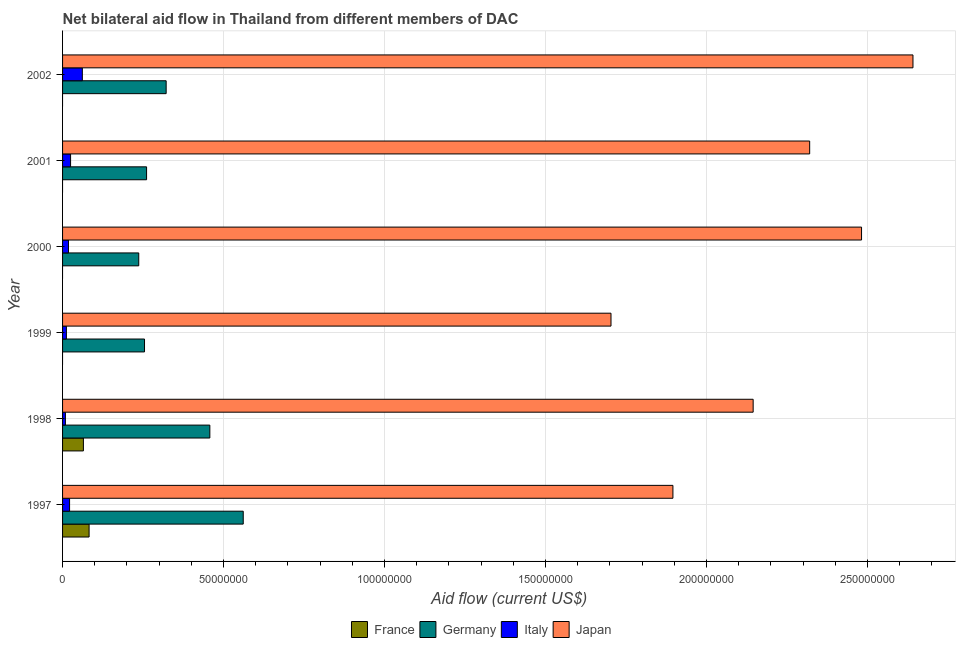Are the number of bars on each tick of the Y-axis equal?
Ensure brevity in your answer.  No. What is the label of the 5th group of bars from the top?
Your answer should be compact. 1998. In how many cases, is the number of bars for a given year not equal to the number of legend labels?
Ensure brevity in your answer.  4. What is the amount of aid given by italy in 1997?
Give a very brief answer. 2.18e+06. Across all years, what is the maximum amount of aid given by italy?
Ensure brevity in your answer.  6.14e+06. Across all years, what is the minimum amount of aid given by japan?
Provide a short and direct response. 1.70e+08. What is the total amount of aid given by japan in the graph?
Give a very brief answer. 1.32e+09. What is the difference between the amount of aid given by italy in 1997 and that in 1999?
Give a very brief answer. 9.90e+05. What is the difference between the amount of aid given by italy in 2001 and the amount of aid given by japan in 1998?
Your answer should be compact. -2.12e+08. What is the average amount of aid given by germany per year?
Offer a very short reply. 3.49e+07. In the year 1997, what is the difference between the amount of aid given by france and amount of aid given by germany?
Your answer should be compact. -4.79e+07. In how many years, is the amount of aid given by france greater than 60000000 US$?
Provide a succinct answer. 0. What is the ratio of the amount of aid given by germany in 1999 to that in 2002?
Your answer should be very brief. 0.79. Is the amount of aid given by italy in 1999 less than that in 2001?
Give a very brief answer. Yes. What is the difference between the highest and the second highest amount of aid given by japan?
Your answer should be compact. 1.60e+07. What is the difference between the highest and the lowest amount of aid given by germany?
Ensure brevity in your answer.  3.24e+07. Is it the case that in every year, the sum of the amount of aid given by germany and amount of aid given by japan is greater than the sum of amount of aid given by italy and amount of aid given by france?
Provide a succinct answer. Yes. Is it the case that in every year, the sum of the amount of aid given by france and amount of aid given by germany is greater than the amount of aid given by italy?
Give a very brief answer. Yes. Are all the bars in the graph horizontal?
Offer a very short reply. Yes. How many years are there in the graph?
Your answer should be very brief. 6. What is the difference between two consecutive major ticks on the X-axis?
Your answer should be compact. 5.00e+07. Does the graph contain grids?
Provide a short and direct response. Yes. How are the legend labels stacked?
Keep it short and to the point. Horizontal. What is the title of the graph?
Keep it short and to the point. Net bilateral aid flow in Thailand from different members of DAC. What is the label or title of the X-axis?
Your response must be concise. Aid flow (current US$). What is the label or title of the Y-axis?
Keep it short and to the point. Year. What is the Aid flow (current US$) of France in 1997?
Provide a succinct answer. 8.24e+06. What is the Aid flow (current US$) of Germany in 1997?
Offer a very short reply. 5.61e+07. What is the Aid flow (current US$) in Italy in 1997?
Provide a succinct answer. 2.18e+06. What is the Aid flow (current US$) in Japan in 1997?
Offer a very short reply. 1.90e+08. What is the Aid flow (current US$) of France in 1998?
Provide a short and direct response. 6.47e+06. What is the Aid flow (current US$) of Germany in 1998?
Offer a very short reply. 4.57e+07. What is the Aid flow (current US$) of Italy in 1998?
Ensure brevity in your answer.  8.80e+05. What is the Aid flow (current US$) of Japan in 1998?
Give a very brief answer. 2.14e+08. What is the Aid flow (current US$) in Germany in 1999?
Make the answer very short. 2.54e+07. What is the Aid flow (current US$) in Italy in 1999?
Ensure brevity in your answer.  1.19e+06. What is the Aid flow (current US$) in Japan in 1999?
Your answer should be very brief. 1.70e+08. What is the Aid flow (current US$) in Germany in 2000?
Offer a very short reply. 2.37e+07. What is the Aid flow (current US$) in Italy in 2000?
Give a very brief answer. 1.84e+06. What is the Aid flow (current US$) of Japan in 2000?
Keep it short and to the point. 2.48e+08. What is the Aid flow (current US$) in France in 2001?
Your response must be concise. 0. What is the Aid flow (current US$) of Germany in 2001?
Ensure brevity in your answer.  2.61e+07. What is the Aid flow (current US$) in Italy in 2001?
Provide a succinct answer. 2.49e+06. What is the Aid flow (current US$) of Japan in 2001?
Offer a very short reply. 2.32e+08. What is the Aid flow (current US$) in Germany in 2002?
Keep it short and to the point. 3.22e+07. What is the Aid flow (current US$) of Italy in 2002?
Offer a very short reply. 6.14e+06. What is the Aid flow (current US$) in Japan in 2002?
Provide a succinct answer. 2.64e+08. Across all years, what is the maximum Aid flow (current US$) of France?
Keep it short and to the point. 8.24e+06. Across all years, what is the maximum Aid flow (current US$) of Germany?
Provide a short and direct response. 5.61e+07. Across all years, what is the maximum Aid flow (current US$) in Italy?
Give a very brief answer. 6.14e+06. Across all years, what is the maximum Aid flow (current US$) of Japan?
Provide a short and direct response. 2.64e+08. Across all years, what is the minimum Aid flow (current US$) of Germany?
Ensure brevity in your answer.  2.37e+07. Across all years, what is the minimum Aid flow (current US$) of Italy?
Offer a very short reply. 8.80e+05. Across all years, what is the minimum Aid flow (current US$) of Japan?
Offer a very short reply. 1.70e+08. What is the total Aid flow (current US$) of France in the graph?
Make the answer very short. 1.47e+07. What is the total Aid flow (current US$) of Germany in the graph?
Make the answer very short. 2.09e+08. What is the total Aid flow (current US$) in Italy in the graph?
Make the answer very short. 1.47e+07. What is the total Aid flow (current US$) in Japan in the graph?
Provide a short and direct response. 1.32e+09. What is the difference between the Aid flow (current US$) in France in 1997 and that in 1998?
Your response must be concise. 1.77e+06. What is the difference between the Aid flow (current US$) of Germany in 1997 and that in 1998?
Ensure brevity in your answer.  1.04e+07. What is the difference between the Aid flow (current US$) of Italy in 1997 and that in 1998?
Your answer should be compact. 1.30e+06. What is the difference between the Aid flow (current US$) in Japan in 1997 and that in 1998?
Your answer should be compact. -2.49e+07. What is the difference between the Aid flow (current US$) in Germany in 1997 and that in 1999?
Provide a short and direct response. 3.07e+07. What is the difference between the Aid flow (current US$) in Italy in 1997 and that in 1999?
Ensure brevity in your answer.  9.90e+05. What is the difference between the Aid flow (current US$) in Japan in 1997 and that in 1999?
Keep it short and to the point. 1.92e+07. What is the difference between the Aid flow (current US$) in Germany in 1997 and that in 2000?
Offer a very short reply. 3.24e+07. What is the difference between the Aid flow (current US$) in Japan in 1997 and that in 2000?
Provide a succinct answer. -5.86e+07. What is the difference between the Aid flow (current US$) in Germany in 1997 and that in 2001?
Offer a terse response. 3.00e+07. What is the difference between the Aid flow (current US$) of Italy in 1997 and that in 2001?
Offer a very short reply. -3.10e+05. What is the difference between the Aid flow (current US$) in Japan in 1997 and that in 2001?
Provide a succinct answer. -4.25e+07. What is the difference between the Aid flow (current US$) in Germany in 1997 and that in 2002?
Give a very brief answer. 2.39e+07. What is the difference between the Aid flow (current US$) in Italy in 1997 and that in 2002?
Offer a terse response. -3.96e+06. What is the difference between the Aid flow (current US$) in Japan in 1997 and that in 2002?
Ensure brevity in your answer.  -7.46e+07. What is the difference between the Aid flow (current US$) in Germany in 1998 and that in 1999?
Offer a terse response. 2.03e+07. What is the difference between the Aid flow (current US$) in Italy in 1998 and that in 1999?
Your response must be concise. -3.10e+05. What is the difference between the Aid flow (current US$) of Japan in 1998 and that in 1999?
Your answer should be very brief. 4.42e+07. What is the difference between the Aid flow (current US$) of Germany in 1998 and that in 2000?
Offer a terse response. 2.21e+07. What is the difference between the Aid flow (current US$) in Italy in 1998 and that in 2000?
Your answer should be compact. -9.60e+05. What is the difference between the Aid flow (current US$) in Japan in 1998 and that in 2000?
Your answer should be compact. -3.37e+07. What is the difference between the Aid flow (current US$) in Germany in 1998 and that in 2001?
Your response must be concise. 1.96e+07. What is the difference between the Aid flow (current US$) of Italy in 1998 and that in 2001?
Provide a succinct answer. -1.61e+06. What is the difference between the Aid flow (current US$) in Japan in 1998 and that in 2001?
Your answer should be compact. -1.76e+07. What is the difference between the Aid flow (current US$) of Germany in 1998 and that in 2002?
Provide a short and direct response. 1.36e+07. What is the difference between the Aid flow (current US$) of Italy in 1998 and that in 2002?
Make the answer very short. -5.26e+06. What is the difference between the Aid flow (current US$) in Japan in 1998 and that in 2002?
Offer a terse response. -4.96e+07. What is the difference between the Aid flow (current US$) in Germany in 1999 and that in 2000?
Your answer should be compact. 1.79e+06. What is the difference between the Aid flow (current US$) of Italy in 1999 and that in 2000?
Provide a succinct answer. -6.50e+05. What is the difference between the Aid flow (current US$) of Japan in 1999 and that in 2000?
Provide a succinct answer. -7.78e+07. What is the difference between the Aid flow (current US$) in Germany in 1999 and that in 2001?
Keep it short and to the point. -6.40e+05. What is the difference between the Aid flow (current US$) of Italy in 1999 and that in 2001?
Your answer should be compact. -1.30e+06. What is the difference between the Aid flow (current US$) of Japan in 1999 and that in 2001?
Make the answer very short. -6.17e+07. What is the difference between the Aid flow (current US$) of Germany in 1999 and that in 2002?
Ensure brevity in your answer.  -6.72e+06. What is the difference between the Aid flow (current US$) in Italy in 1999 and that in 2002?
Your answer should be very brief. -4.95e+06. What is the difference between the Aid flow (current US$) in Japan in 1999 and that in 2002?
Your response must be concise. -9.38e+07. What is the difference between the Aid flow (current US$) of Germany in 2000 and that in 2001?
Provide a succinct answer. -2.43e+06. What is the difference between the Aid flow (current US$) of Italy in 2000 and that in 2001?
Your answer should be compact. -6.50e+05. What is the difference between the Aid flow (current US$) in Japan in 2000 and that in 2001?
Keep it short and to the point. 1.61e+07. What is the difference between the Aid flow (current US$) of Germany in 2000 and that in 2002?
Offer a very short reply. -8.51e+06. What is the difference between the Aid flow (current US$) of Italy in 2000 and that in 2002?
Ensure brevity in your answer.  -4.30e+06. What is the difference between the Aid flow (current US$) in Japan in 2000 and that in 2002?
Offer a very short reply. -1.60e+07. What is the difference between the Aid flow (current US$) of Germany in 2001 and that in 2002?
Offer a very short reply. -6.08e+06. What is the difference between the Aid flow (current US$) in Italy in 2001 and that in 2002?
Keep it short and to the point. -3.65e+06. What is the difference between the Aid flow (current US$) of Japan in 2001 and that in 2002?
Provide a succinct answer. -3.21e+07. What is the difference between the Aid flow (current US$) of France in 1997 and the Aid flow (current US$) of Germany in 1998?
Your answer should be compact. -3.75e+07. What is the difference between the Aid flow (current US$) of France in 1997 and the Aid flow (current US$) of Italy in 1998?
Make the answer very short. 7.36e+06. What is the difference between the Aid flow (current US$) in France in 1997 and the Aid flow (current US$) in Japan in 1998?
Provide a short and direct response. -2.06e+08. What is the difference between the Aid flow (current US$) of Germany in 1997 and the Aid flow (current US$) of Italy in 1998?
Offer a terse response. 5.52e+07. What is the difference between the Aid flow (current US$) of Germany in 1997 and the Aid flow (current US$) of Japan in 1998?
Your answer should be compact. -1.58e+08. What is the difference between the Aid flow (current US$) of Italy in 1997 and the Aid flow (current US$) of Japan in 1998?
Provide a short and direct response. -2.12e+08. What is the difference between the Aid flow (current US$) in France in 1997 and the Aid flow (current US$) in Germany in 1999?
Ensure brevity in your answer.  -1.72e+07. What is the difference between the Aid flow (current US$) of France in 1997 and the Aid flow (current US$) of Italy in 1999?
Give a very brief answer. 7.05e+06. What is the difference between the Aid flow (current US$) of France in 1997 and the Aid flow (current US$) of Japan in 1999?
Provide a succinct answer. -1.62e+08. What is the difference between the Aid flow (current US$) in Germany in 1997 and the Aid flow (current US$) in Italy in 1999?
Ensure brevity in your answer.  5.49e+07. What is the difference between the Aid flow (current US$) of Germany in 1997 and the Aid flow (current US$) of Japan in 1999?
Give a very brief answer. -1.14e+08. What is the difference between the Aid flow (current US$) of Italy in 1997 and the Aid flow (current US$) of Japan in 1999?
Keep it short and to the point. -1.68e+08. What is the difference between the Aid flow (current US$) of France in 1997 and the Aid flow (current US$) of Germany in 2000?
Keep it short and to the point. -1.54e+07. What is the difference between the Aid flow (current US$) of France in 1997 and the Aid flow (current US$) of Italy in 2000?
Provide a short and direct response. 6.40e+06. What is the difference between the Aid flow (current US$) in France in 1997 and the Aid flow (current US$) in Japan in 2000?
Keep it short and to the point. -2.40e+08. What is the difference between the Aid flow (current US$) in Germany in 1997 and the Aid flow (current US$) in Italy in 2000?
Ensure brevity in your answer.  5.43e+07. What is the difference between the Aid flow (current US$) in Germany in 1997 and the Aid flow (current US$) in Japan in 2000?
Keep it short and to the point. -1.92e+08. What is the difference between the Aid flow (current US$) of Italy in 1997 and the Aid flow (current US$) of Japan in 2000?
Offer a very short reply. -2.46e+08. What is the difference between the Aid flow (current US$) of France in 1997 and the Aid flow (current US$) of Germany in 2001?
Your answer should be compact. -1.78e+07. What is the difference between the Aid flow (current US$) of France in 1997 and the Aid flow (current US$) of Italy in 2001?
Offer a very short reply. 5.75e+06. What is the difference between the Aid flow (current US$) in France in 1997 and the Aid flow (current US$) in Japan in 2001?
Your answer should be very brief. -2.24e+08. What is the difference between the Aid flow (current US$) of Germany in 1997 and the Aid flow (current US$) of Italy in 2001?
Give a very brief answer. 5.36e+07. What is the difference between the Aid flow (current US$) of Germany in 1997 and the Aid flow (current US$) of Japan in 2001?
Your answer should be compact. -1.76e+08. What is the difference between the Aid flow (current US$) in Italy in 1997 and the Aid flow (current US$) in Japan in 2001?
Your answer should be very brief. -2.30e+08. What is the difference between the Aid flow (current US$) of France in 1997 and the Aid flow (current US$) of Germany in 2002?
Your response must be concise. -2.39e+07. What is the difference between the Aid flow (current US$) in France in 1997 and the Aid flow (current US$) in Italy in 2002?
Make the answer very short. 2.10e+06. What is the difference between the Aid flow (current US$) of France in 1997 and the Aid flow (current US$) of Japan in 2002?
Ensure brevity in your answer.  -2.56e+08. What is the difference between the Aid flow (current US$) of Germany in 1997 and the Aid flow (current US$) of Italy in 2002?
Your answer should be compact. 5.00e+07. What is the difference between the Aid flow (current US$) of Germany in 1997 and the Aid flow (current US$) of Japan in 2002?
Keep it short and to the point. -2.08e+08. What is the difference between the Aid flow (current US$) in Italy in 1997 and the Aid flow (current US$) in Japan in 2002?
Make the answer very short. -2.62e+08. What is the difference between the Aid flow (current US$) in France in 1998 and the Aid flow (current US$) in Germany in 1999?
Keep it short and to the point. -1.90e+07. What is the difference between the Aid flow (current US$) in France in 1998 and the Aid flow (current US$) in Italy in 1999?
Offer a terse response. 5.28e+06. What is the difference between the Aid flow (current US$) in France in 1998 and the Aid flow (current US$) in Japan in 1999?
Offer a very short reply. -1.64e+08. What is the difference between the Aid flow (current US$) in Germany in 1998 and the Aid flow (current US$) in Italy in 1999?
Provide a short and direct response. 4.46e+07. What is the difference between the Aid flow (current US$) of Germany in 1998 and the Aid flow (current US$) of Japan in 1999?
Ensure brevity in your answer.  -1.25e+08. What is the difference between the Aid flow (current US$) of Italy in 1998 and the Aid flow (current US$) of Japan in 1999?
Keep it short and to the point. -1.69e+08. What is the difference between the Aid flow (current US$) in France in 1998 and the Aid flow (current US$) in Germany in 2000?
Your answer should be very brief. -1.72e+07. What is the difference between the Aid flow (current US$) in France in 1998 and the Aid flow (current US$) in Italy in 2000?
Your response must be concise. 4.63e+06. What is the difference between the Aid flow (current US$) of France in 1998 and the Aid flow (current US$) of Japan in 2000?
Your answer should be very brief. -2.42e+08. What is the difference between the Aid flow (current US$) of Germany in 1998 and the Aid flow (current US$) of Italy in 2000?
Provide a succinct answer. 4.39e+07. What is the difference between the Aid flow (current US$) in Germany in 1998 and the Aid flow (current US$) in Japan in 2000?
Your answer should be very brief. -2.02e+08. What is the difference between the Aid flow (current US$) of Italy in 1998 and the Aid flow (current US$) of Japan in 2000?
Give a very brief answer. -2.47e+08. What is the difference between the Aid flow (current US$) of France in 1998 and the Aid flow (current US$) of Germany in 2001?
Provide a short and direct response. -1.96e+07. What is the difference between the Aid flow (current US$) in France in 1998 and the Aid flow (current US$) in Italy in 2001?
Your response must be concise. 3.98e+06. What is the difference between the Aid flow (current US$) of France in 1998 and the Aid flow (current US$) of Japan in 2001?
Keep it short and to the point. -2.26e+08. What is the difference between the Aid flow (current US$) in Germany in 1998 and the Aid flow (current US$) in Italy in 2001?
Offer a very short reply. 4.32e+07. What is the difference between the Aid flow (current US$) in Germany in 1998 and the Aid flow (current US$) in Japan in 2001?
Provide a short and direct response. -1.86e+08. What is the difference between the Aid flow (current US$) of Italy in 1998 and the Aid flow (current US$) of Japan in 2001?
Provide a short and direct response. -2.31e+08. What is the difference between the Aid flow (current US$) in France in 1998 and the Aid flow (current US$) in Germany in 2002?
Your response must be concise. -2.57e+07. What is the difference between the Aid flow (current US$) of France in 1998 and the Aid flow (current US$) of Japan in 2002?
Your answer should be compact. -2.58e+08. What is the difference between the Aid flow (current US$) of Germany in 1998 and the Aid flow (current US$) of Italy in 2002?
Keep it short and to the point. 3.96e+07. What is the difference between the Aid flow (current US$) in Germany in 1998 and the Aid flow (current US$) in Japan in 2002?
Provide a succinct answer. -2.18e+08. What is the difference between the Aid flow (current US$) in Italy in 1998 and the Aid flow (current US$) in Japan in 2002?
Offer a very short reply. -2.63e+08. What is the difference between the Aid flow (current US$) of Germany in 1999 and the Aid flow (current US$) of Italy in 2000?
Offer a very short reply. 2.36e+07. What is the difference between the Aid flow (current US$) in Germany in 1999 and the Aid flow (current US$) in Japan in 2000?
Make the answer very short. -2.23e+08. What is the difference between the Aid flow (current US$) in Italy in 1999 and the Aid flow (current US$) in Japan in 2000?
Give a very brief answer. -2.47e+08. What is the difference between the Aid flow (current US$) in Germany in 1999 and the Aid flow (current US$) in Italy in 2001?
Give a very brief answer. 2.30e+07. What is the difference between the Aid flow (current US$) of Germany in 1999 and the Aid flow (current US$) of Japan in 2001?
Keep it short and to the point. -2.07e+08. What is the difference between the Aid flow (current US$) in Italy in 1999 and the Aid flow (current US$) in Japan in 2001?
Your answer should be compact. -2.31e+08. What is the difference between the Aid flow (current US$) in Germany in 1999 and the Aid flow (current US$) in Italy in 2002?
Provide a succinct answer. 1.93e+07. What is the difference between the Aid flow (current US$) of Germany in 1999 and the Aid flow (current US$) of Japan in 2002?
Offer a very short reply. -2.39e+08. What is the difference between the Aid flow (current US$) of Italy in 1999 and the Aid flow (current US$) of Japan in 2002?
Offer a terse response. -2.63e+08. What is the difference between the Aid flow (current US$) of Germany in 2000 and the Aid flow (current US$) of Italy in 2001?
Provide a short and direct response. 2.12e+07. What is the difference between the Aid flow (current US$) in Germany in 2000 and the Aid flow (current US$) in Japan in 2001?
Provide a short and direct response. -2.08e+08. What is the difference between the Aid flow (current US$) of Italy in 2000 and the Aid flow (current US$) of Japan in 2001?
Offer a terse response. -2.30e+08. What is the difference between the Aid flow (current US$) of Germany in 2000 and the Aid flow (current US$) of Italy in 2002?
Offer a terse response. 1.75e+07. What is the difference between the Aid flow (current US$) of Germany in 2000 and the Aid flow (current US$) of Japan in 2002?
Give a very brief answer. -2.40e+08. What is the difference between the Aid flow (current US$) of Italy in 2000 and the Aid flow (current US$) of Japan in 2002?
Offer a very short reply. -2.62e+08. What is the difference between the Aid flow (current US$) in Germany in 2001 and the Aid flow (current US$) in Italy in 2002?
Offer a very short reply. 2.00e+07. What is the difference between the Aid flow (current US$) of Germany in 2001 and the Aid flow (current US$) of Japan in 2002?
Offer a very short reply. -2.38e+08. What is the difference between the Aid flow (current US$) in Italy in 2001 and the Aid flow (current US$) in Japan in 2002?
Offer a very short reply. -2.62e+08. What is the average Aid flow (current US$) in France per year?
Provide a succinct answer. 2.45e+06. What is the average Aid flow (current US$) of Germany per year?
Your response must be concise. 3.49e+07. What is the average Aid flow (current US$) in Italy per year?
Provide a succinct answer. 2.45e+06. What is the average Aid flow (current US$) of Japan per year?
Keep it short and to the point. 2.20e+08. In the year 1997, what is the difference between the Aid flow (current US$) in France and Aid flow (current US$) in Germany?
Your answer should be very brief. -4.79e+07. In the year 1997, what is the difference between the Aid flow (current US$) in France and Aid flow (current US$) in Italy?
Give a very brief answer. 6.06e+06. In the year 1997, what is the difference between the Aid flow (current US$) in France and Aid flow (current US$) in Japan?
Ensure brevity in your answer.  -1.81e+08. In the year 1997, what is the difference between the Aid flow (current US$) of Germany and Aid flow (current US$) of Italy?
Your answer should be very brief. 5.39e+07. In the year 1997, what is the difference between the Aid flow (current US$) of Germany and Aid flow (current US$) of Japan?
Your answer should be compact. -1.33e+08. In the year 1997, what is the difference between the Aid flow (current US$) of Italy and Aid flow (current US$) of Japan?
Give a very brief answer. -1.87e+08. In the year 1998, what is the difference between the Aid flow (current US$) in France and Aid flow (current US$) in Germany?
Your response must be concise. -3.93e+07. In the year 1998, what is the difference between the Aid flow (current US$) in France and Aid flow (current US$) in Italy?
Your response must be concise. 5.59e+06. In the year 1998, what is the difference between the Aid flow (current US$) in France and Aid flow (current US$) in Japan?
Your response must be concise. -2.08e+08. In the year 1998, what is the difference between the Aid flow (current US$) in Germany and Aid flow (current US$) in Italy?
Ensure brevity in your answer.  4.49e+07. In the year 1998, what is the difference between the Aid flow (current US$) in Germany and Aid flow (current US$) in Japan?
Offer a terse response. -1.69e+08. In the year 1998, what is the difference between the Aid flow (current US$) in Italy and Aid flow (current US$) in Japan?
Ensure brevity in your answer.  -2.14e+08. In the year 1999, what is the difference between the Aid flow (current US$) of Germany and Aid flow (current US$) of Italy?
Your answer should be very brief. 2.43e+07. In the year 1999, what is the difference between the Aid flow (current US$) in Germany and Aid flow (current US$) in Japan?
Make the answer very short. -1.45e+08. In the year 1999, what is the difference between the Aid flow (current US$) of Italy and Aid flow (current US$) of Japan?
Offer a terse response. -1.69e+08. In the year 2000, what is the difference between the Aid flow (current US$) of Germany and Aid flow (current US$) of Italy?
Ensure brevity in your answer.  2.18e+07. In the year 2000, what is the difference between the Aid flow (current US$) of Germany and Aid flow (current US$) of Japan?
Offer a very short reply. -2.24e+08. In the year 2000, what is the difference between the Aid flow (current US$) of Italy and Aid flow (current US$) of Japan?
Ensure brevity in your answer.  -2.46e+08. In the year 2001, what is the difference between the Aid flow (current US$) in Germany and Aid flow (current US$) in Italy?
Your answer should be compact. 2.36e+07. In the year 2001, what is the difference between the Aid flow (current US$) of Germany and Aid flow (current US$) of Japan?
Offer a terse response. -2.06e+08. In the year 2001, what is the difference between the Aid flow (current US$) in Italy and Aid flow (current US$) in Japan?
Offer a terse response. -2.30e+08. In the year 2002, what is the difference between the Aid flow (current US$) of Germany and Aid flow (current US$) of Italy?
Keep it short and to the point. 2.60e+07. In the year 2002, what is the difference between the Aid flow (current US$) in Germany and Aid flow (current US$) in Japan?
Provide a short and direct response. -2.32e+08. In the year 2002, what is the difference between the Aid flow (current US$) of Italy and Aid flow (current US$) of Japan?
Make the answer very short. -2.58e+08. What is the ratio of the Aid flow (current US$) of France in 1997 to that in 1998?
Offer a terse response. 1.27. What is the ratio of the Aid flow (current US$) of Germany in 1997 to that in 1998?
Give a very brief answer. 1.23. What is the ratio of the Aid flow (current US$) in Italy in 1997 to that in 1998?
Keep it short and to the point. 2.48. What is the ratio of the Aid flow (current US$) in Japan in 1997 to that in 1998?
Your answer should be compact. 0.88. What is the ratio of the Aid flow (current US$) in Germany in 1997 to that in 1999?
Give a very brief answer. 2.2. What is the ratio of the Aid flow (current US$) of Italy in 1997 to that in 1999?
Give a very brief answer. 1.83. What is the ratio of the Aid flow (current US$) in Japan in 1997 to that in 1999?
Your response must be concise. 1.11. What is the ratio of the Aid flow (current US$) of Germany in 1997 to that in 2000?
Ensure brevity in your answer.  2.37. What is the ratio of the Aid flow (current US$) of Italy in 1997 to that in 2000?
Your response must be concise. 1.18. What is the ratio of the Aid flow (current US$) of Japan in 1997 to that in 2000?
Provide a short and direct response. 0.76. What is the ratio of the Aid flow (current US$) of Germany in 1997 to that in 2001?
Offer a very short reply. 2.15. What is the ratio of the Aid flow (current US$) of Italy in 1997 to that in 2001?
Keep it short and to the point. 0.88. What is the ratio of the Aid flow (current US$) in Japan in 1997 to that in 2001?
Your response must be concise. 0.82. What is the ratio of the Aid flow (current US$) in Germany in 1997 to that in 2002?
Ensure brevity in your answer.  1.74. What is the ratio of the Aid flow (current US$) in Italy in 1997 to that in 2002?
Offer a very short reply. 0.35. What is the ratio of the Aid flow (current US$) in Japan in 1997 to that in 2002?
Keep it short and to the point. 0.72. What is the ratio of the Aid flow (current US$) of Germany in 1998 to that in 1999?
Offer a terse response. 1.8. What is the ratio of the Aid flow (current US$) in Italy in 1998 to that in 1999?
Keep it short and to the point. 0.74. What is the ratio of the Aid flow (current US$) in Japan in 1998 to that in 1999?
Your answer should be compact. 1.26. What is the ratio of the Aid flow (current US$) of Germany in 1998 to that in 2000?
Ensure brevity in your answer.  1.93. What is the ratio of the Aid flow (current US$) in Italy in 1998 to that in 2000?
Your answer should be very brief. 0.48. What is the ratio of the Aid flow (current US$) in Japan in 1998 to that in 2000?
Keep it short and to the point. 0.86. What is the ratio of the Aid flow (current US$) of Germany in 1998 to that in 2001?
Offer a very short reply. 1.75. What is the ratio of the Aid flow (current US$) in Italy in 1998 to that in 2001?
Keep it short and to the point. 0.35. What is the ratio of the Aid flow (current US$) in Japan in 1998 to that in 2001?
Offer a terse response. 0.92. What is the ratio of the Aid flow (current US$) in Germany in 1998 to that in 2002?
Keep it short and to the point. 1.42. What is the ratio of the Aid flow (current US$) of Italy in 1998 to that in 2002?
Provide a short and direct response. 0.14. What is the ratio of the Aid flow (current US$) in Japan in 1998 to that in 2002?
Give a very brief answer. 0.81. What is the ratio of the Aid flow (current US$) of Germany in 1999 to that in 2000?
Offer a terse response. 1.08. What is the ratio of the Aid flow (current US$) of Italy in 1999 to that in 2000?
Ensure brevity in your answer.  0.65. What is the ratio of the Aid flow (current US$) of Japan in 1999 to that in 2000?
Offer a very short reply. 0.69. What is the ratio of the Aid flow (current US$) of Germany in 1999 to that in 2001?
Offer a very short reply. 0.98. What is the ratio of the Aid flow (current US$) of Italy in 1999 to that in 2001?
Make the answer very short. 0.48. What is the ratio of the Aid flow (current US$) of Japan in 1999 to that in 2001?
Your answer should be compact. 0.73. What is the ratio of the Aid flow (current US$) in Germany in 1999 to that in 2002?
Your answer should be very brief. 0.79. What is the ratio of the Aid flow (current US$) in Italy in 1999 to that in 2002?
Make the answer very short. 0.19. What is the ratio of the Aid flow (current US$) of Japan in 1999 to that in 2002?
Offer a terse response. 0.64. What is the ratio of the Aid flow (current US$) of Germany in 2000 to that in 2001?
Provide a short and direct response. 0.91. What is the ratio of the Aid flow (current US$) of Italy in 2000 to that in 2001?
Keep it short and to the point. 0.74. What is the ratio of the Aid flow (current US$) in Japan in 2000 to that in 2001?
Ensure brevity in your answer.  1.07. What is the ratio of the Aid flow (current US$) in Germany in 2000 to that in 2002?
Offer a very short reply. 0.74. What is the ratio of the Aid flow (current US$) in Italy in 2000 to that in 2002?
Your answer should be very brief. 0.3. What is the ratio of the Aid flow (current US$) of Japan in 2000 to that in 2002?
Your answer should be compact. 0.94. What is the ratio of the Aid flow (current US$) in Germany in 2001 to that in 2002?
Provide a succinct answer. 0.81. What is the ratio of the Aid flow (current US$) in Italy in 2001 to that in 2002?
Provide a short and direct response. 0.41. What is the ratio of the Aid flow (current US$) in Japan in 2001 to that in 2002?
Ensure brevity in your answer.  0.88. What is the difference between the highest and the second highest Aid flow (current US$) of Germany?
Provide a succinct answer. 1.04e+07. What is the difference between the highest and the second highest Aid flow (current US$) of Italy?
Offer a very short reply. 3.65e+06. What is the difference between the highest and the second highest Aid flow (current US$) of Japan?
Your answer should be compact. 1.60e+07. What is the difference between the highest and the lowest Aid flow (current US$) of France?
Your answer should be very brief. 8.24e+06. What is the difference between the highest and the lowest Aid flow (current US$) of Germany?
Ensure brevity in your answer.  3.24e+07. What is the difference between the highest and the lowest Aid flow (current US$) of Italy?
Make the answer very short. 5.26e+06. What is the difference between the highest and the lowest Aid flow (current US$) in Japan?
Give a very brief answer. 9.38e+07. 